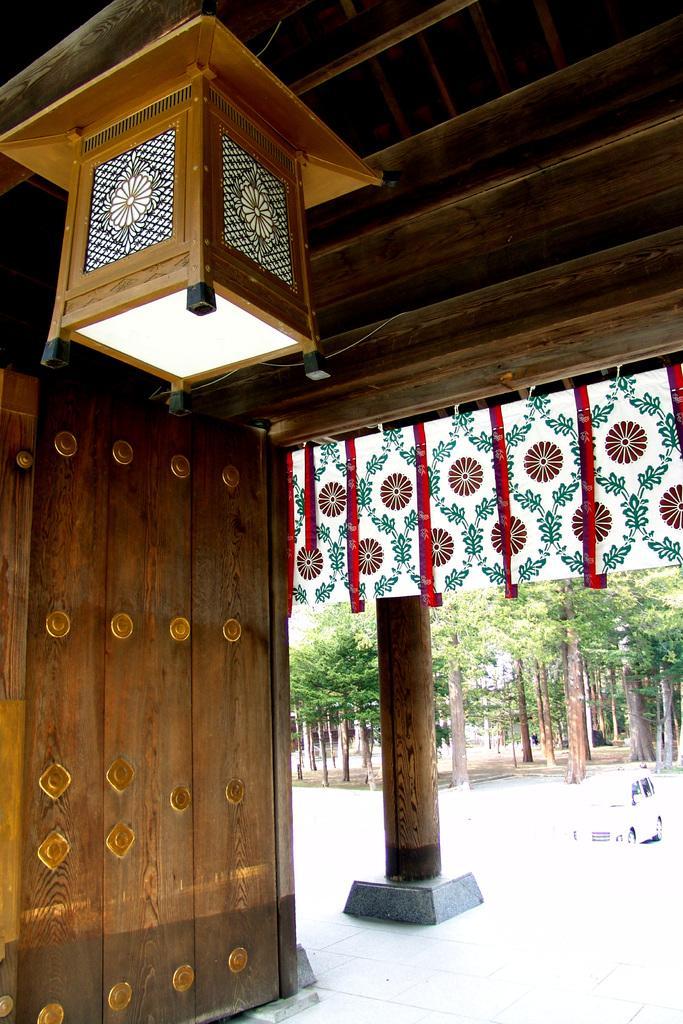Could you give a brief overview of what you see in this image? In this image in the foreground there is one box and wooden wall, in the background there are some trees, pillar and board. At the top there is ceiling and at the bottom there is floor, in the center there is one vehicle. 